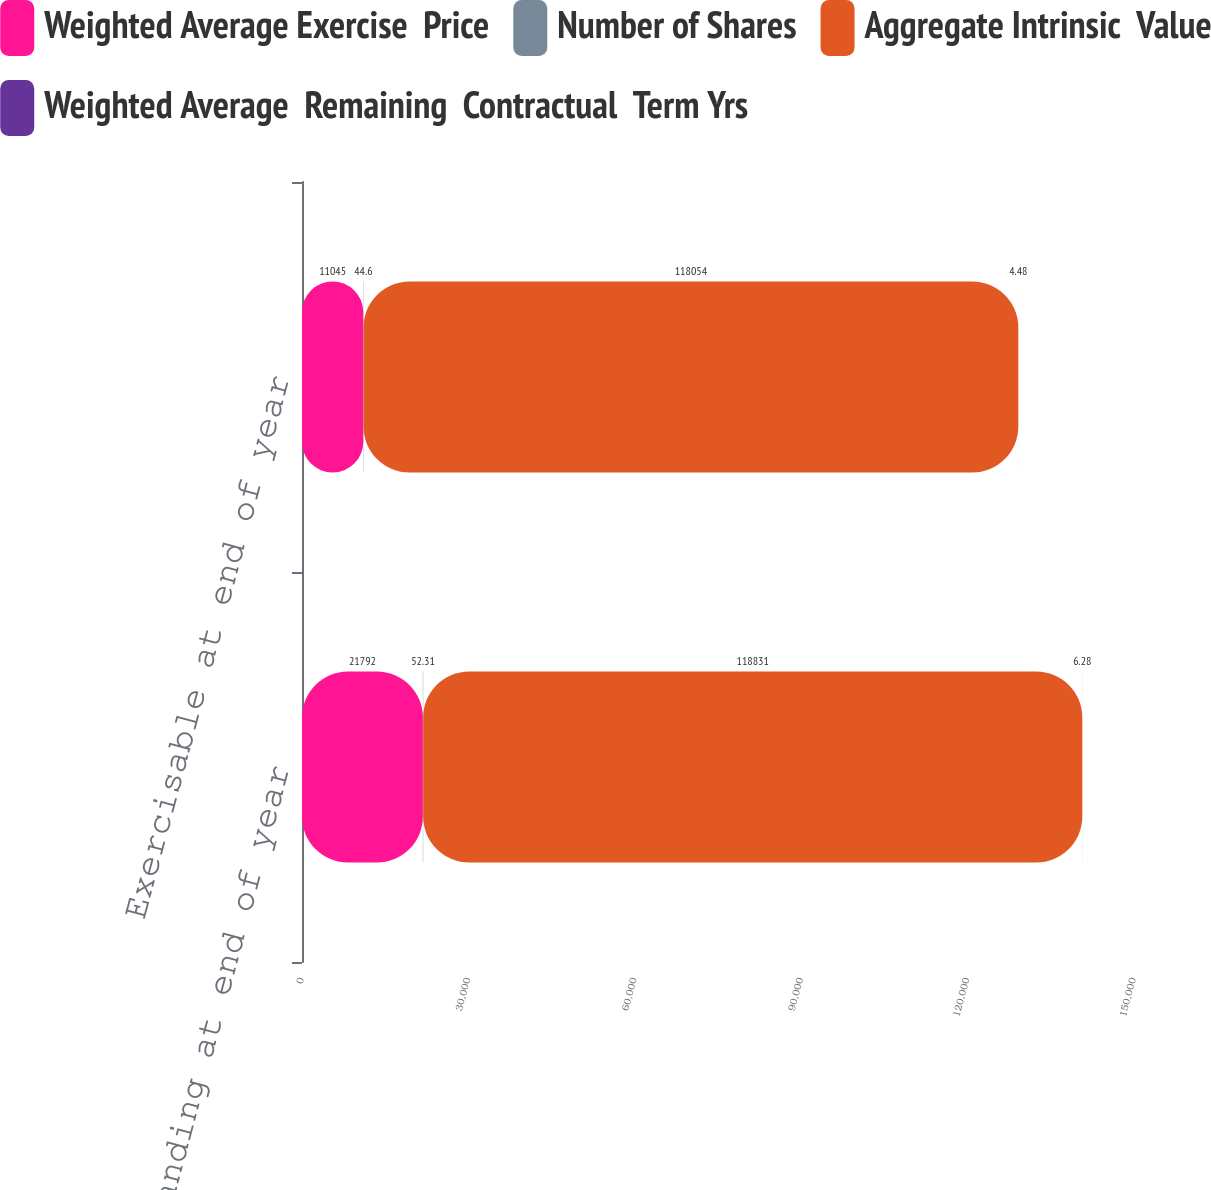<chart> <loc_0><loc_0><loc_500><loc_500><stacked_bar_chart><ecel><fcel>Outstanding at end of year<fcel>Exercisable at end of year<nl><fcel>Weighted Average Exercise  Price<fcel>21792<fcel>11045<nl><fcel>Number of Shares<fcel>52.31<fcel>44.6<nl><fcel>Aggregate Intrinsic  Value<fcel>118831<fcel>118054<nl><fcel>Weighted Average  Remaining  Contractual  Term Yrs<fcel>6.28<fcel>4.48<nl></chart> 